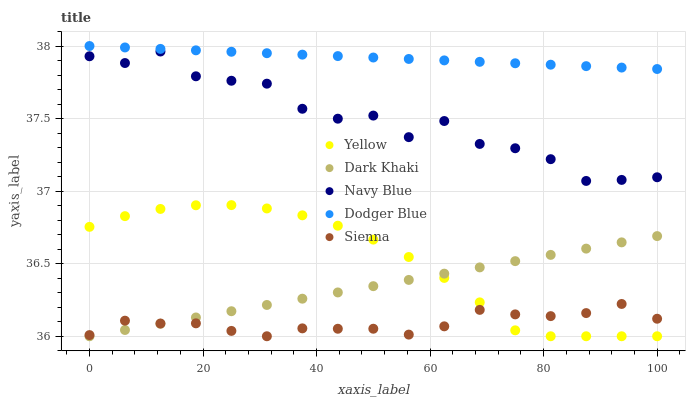Does Sienna have the minimum area under the curve?
Answer yes or no. Yes. Does Dodger Blue have the maximum area under the curve?
Answer yes or no. Yes. Does Navy Blue have the minimum area under the curve?
Answer yes or no. No. Does Navy Blue have the maximum area under the curve?
Answer yes or no. No. Is Dark Khaki the smoothest?
Answer yes or no. Yes. Is Navy Blue the roughest?
Answer yes or no. Yes. Is Dodger Blue the smoothest?
Answer yes or no. No. Is Dodger Blue the roughest?
Answer yes or no. No. Does Dark Khaki have the lowest value?
Answer yes or no. Yes. Does Navy Blue have the lowest value?
Answer yes or no. No. Does Dodger Blue have the highest value?
Answer yes or no. Yes. Does Navy Blue have the highest value?
Answer yes or no. No. Is Yellow less than Navy Blue?
Answer yes or no. Yes. Is Dodger Blue greater than Yellow?
Answer yes or no. Yes. Does Sienna intersect Dark Khaki?
Answer yes or no. Yes. Is Sienna less than Dark Khaki?
Answer yes or no. No. Is Sienna greater than Dark Khaki?
Answer yes or no. No. Does Yellow intersect Navy Blue?
Answer yes or no. No. 